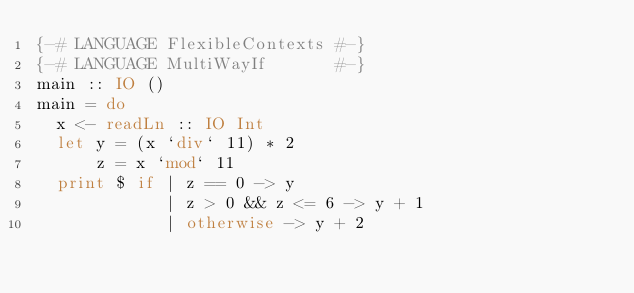<code> <loc_0><loc_0><loc_500><loc_500><_Haskell_>{-# LANGUAGE FlexibleContexts #-}
{-# LANGUAGE MultiWayIf       #-}
main :: IO ()
main = do
  x <- readLn :: IO Int
  let y = (x `div` 11) * 2
      z = x `mod` 11
  print $ if | z == 0 -> y
             | z > 0 && z <= 6 -> y + 1
             | otherwise -> y + 2
</code> 